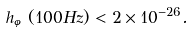<formula> <loc_0><loc_0><loc_500><loc_500>h _ { \varphi } ( 1 0 0 H z ) < 2 \times 1 0 ^ { - 2 6 } .</formula> 